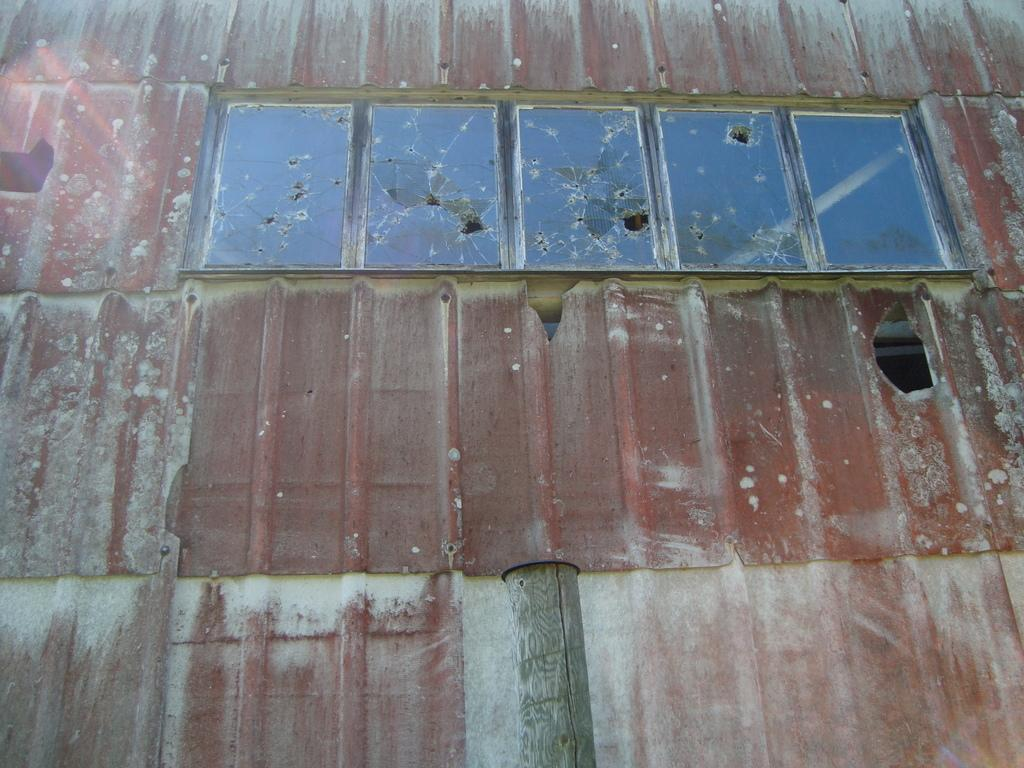What type of structure is depicted in the image? The image appears to be the top of a house. What feature can be seen on the structure? There are glass windows visible at the top of the image. What type of conversation is the father having with his jeans in the image? There is no father or jeans present in the image; it only shows the top of a house with glass windows. 